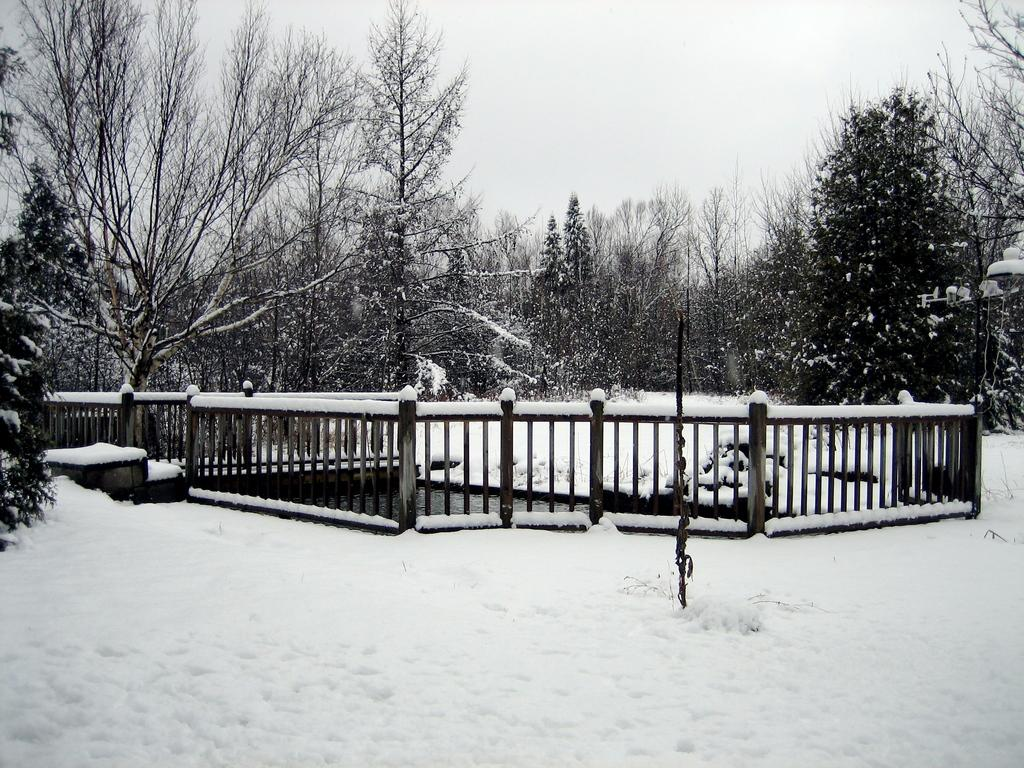What character is present in the image? There is a snow white in the image. What type of structure can be seen in the image? There is a fence in the image. What type of vegetation is present in the image? There is a plant and trees in the image. What part of the natural environment is visible in the image? The sky is visible in the image. What is the rate of the horses running in the image? There are no horses present in the image, so it is not possible to determine their rate of running. 